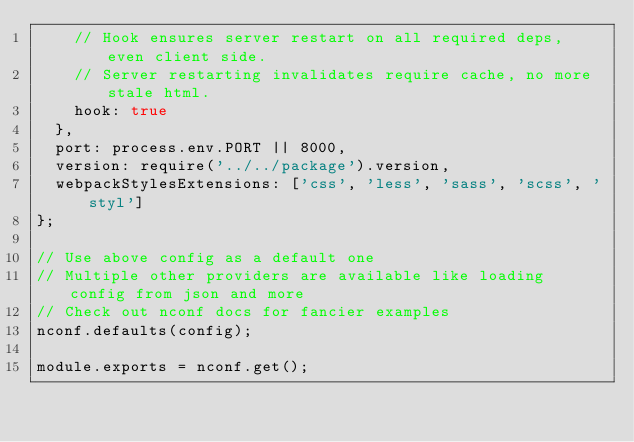<code> <loc_0><loc_0><loc_500><loc_500><_JavaScript_>    // Hook ensures server restart on all required deps, even client side.
    // Server restarting invalidates require cache, no more stale html.
    hook: true
  },
  port: process.env.PORT || 8000,
  version: require('../../package').version,
  webpackStylesExtensions: ['css', 'less', 'sass', 'scss', 'styl']
};

// Use above config as a default one
// Multiple other providers are available like loading config from json and more
// Check out nconf docs for fancier examples
nconf.defaults(config);

module.exports = nconf.get();
</code> 